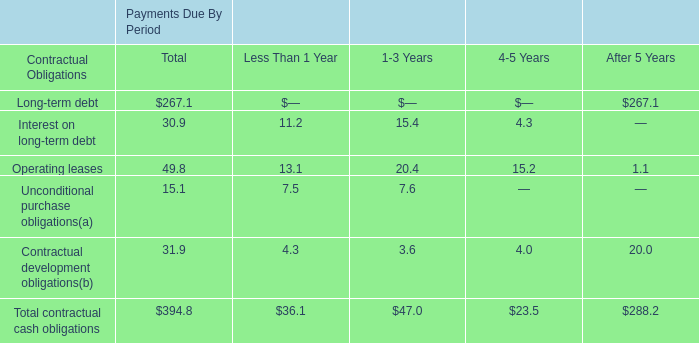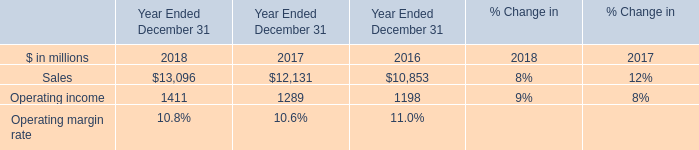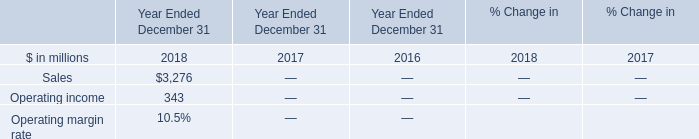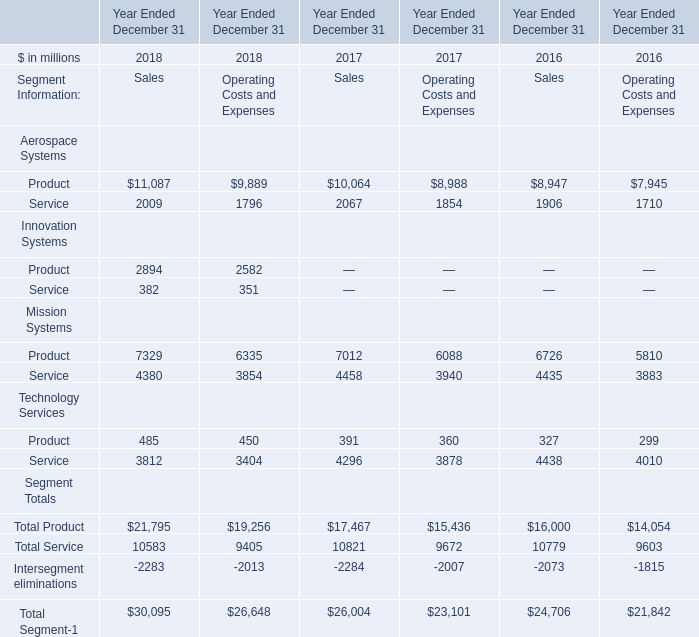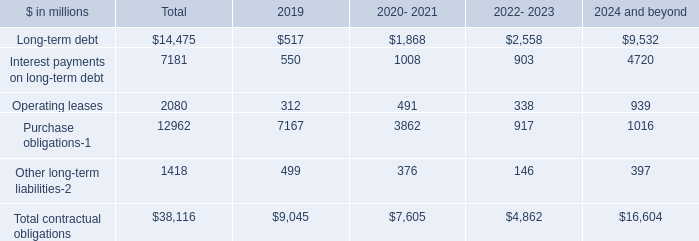What is the sum of Service Technology Services of Year Ended December 31 2018 Sales, Operating income of Year Ended December 31 2018, and Service Technology Services of Year Ended December 31 2017 Sales ? 
Computations: ((3812.0 + 1411.0) + 4296.0)
Answer: 9519.0. 